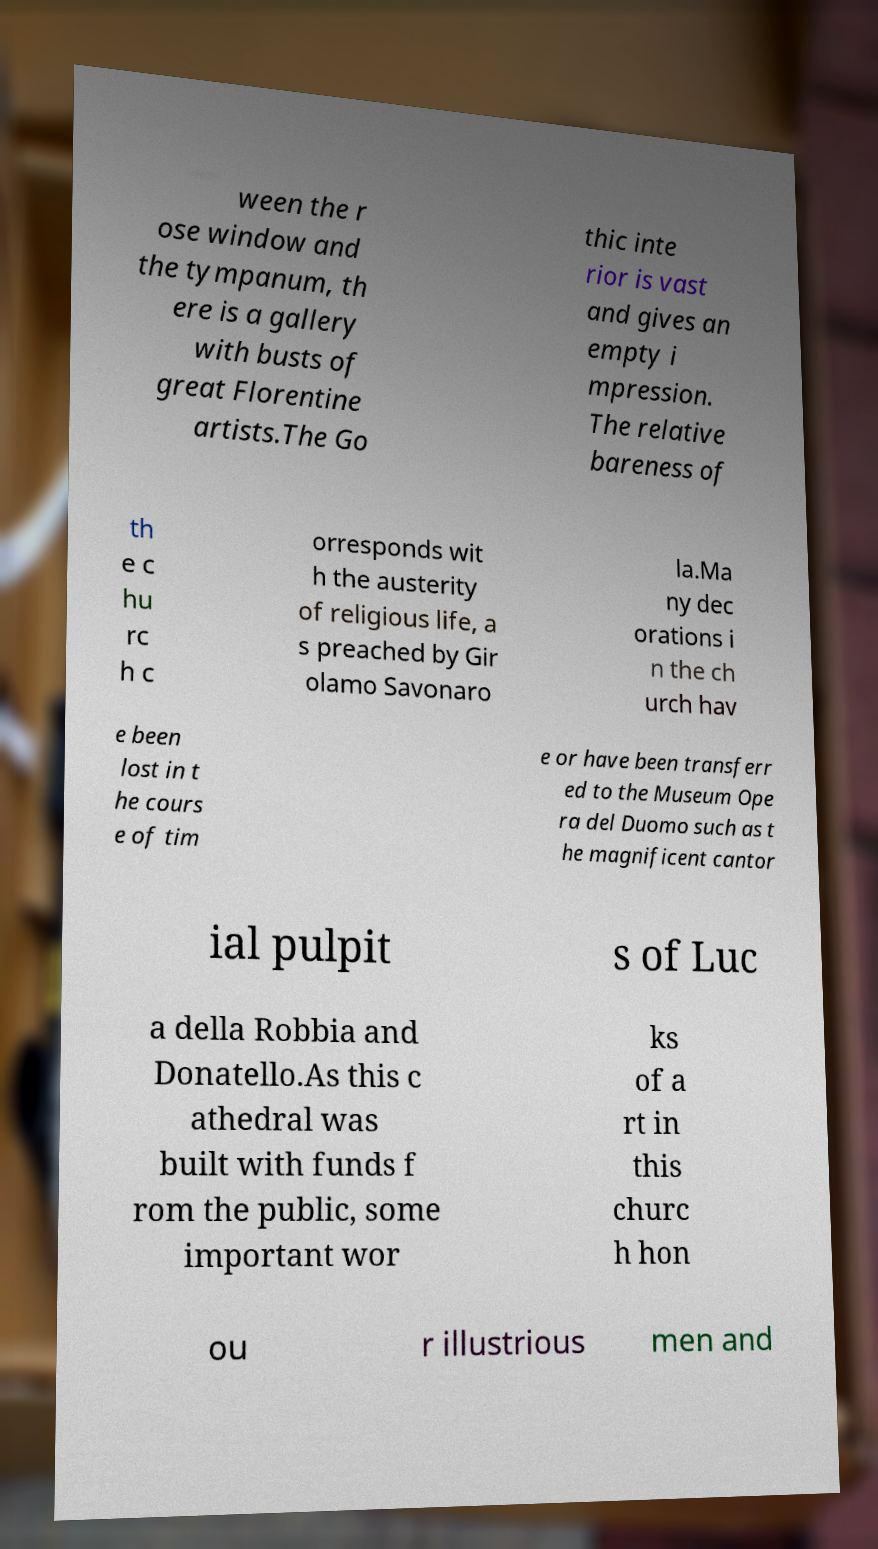Can you accurately transcribe the text from the provided image for me? ween the r ose window and the tympanum, th ere is a gallery with busts of great Florentine artists.The Go thic inte rior is vast and gives an empty i mpression. The relative bareness of th e c hu rc h c orresponds wit h the austerity of religious life, a s preached by Gir olamo Savonaro la.Ma ny dec orations i n the ch urch hav e been lost in t he cours e of tim e or have been transferr ed to the Museum Ope ra del Duomo such as t he magnificent cantor ial pulpit s of Luc a della Robbia and Donatello.As this c athedral was built with funds f rom the public, some important wor ks of a rt in this churc h hon ou r illustrious men and 